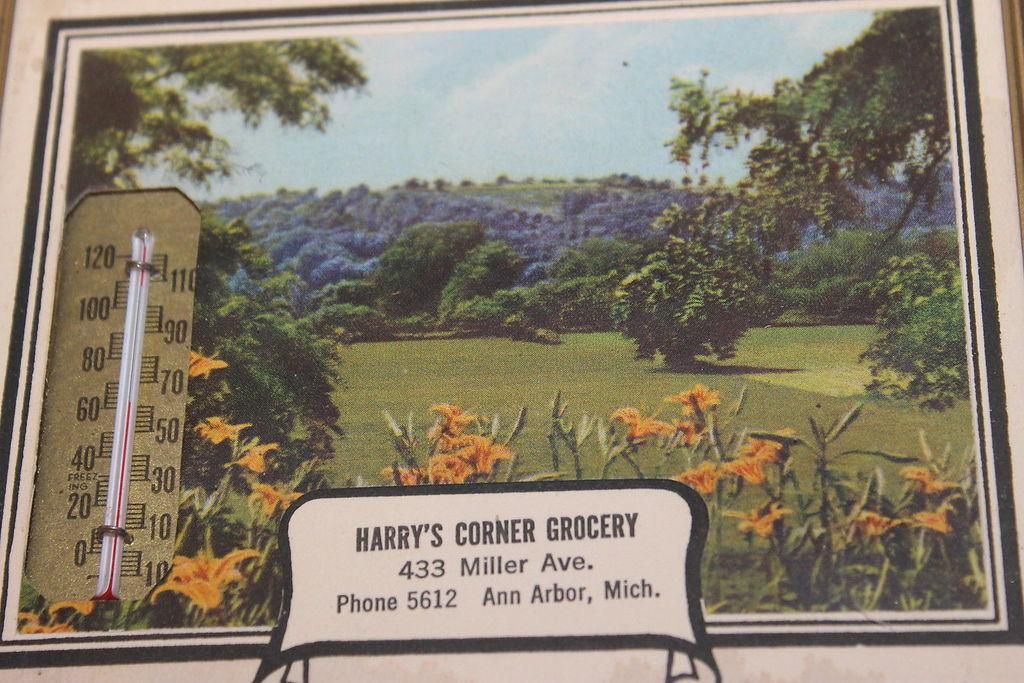Provide a one-sentence caption for the provided image. Harry's Corner Grocery is located at 433 Miller Ave., according to this sign. 